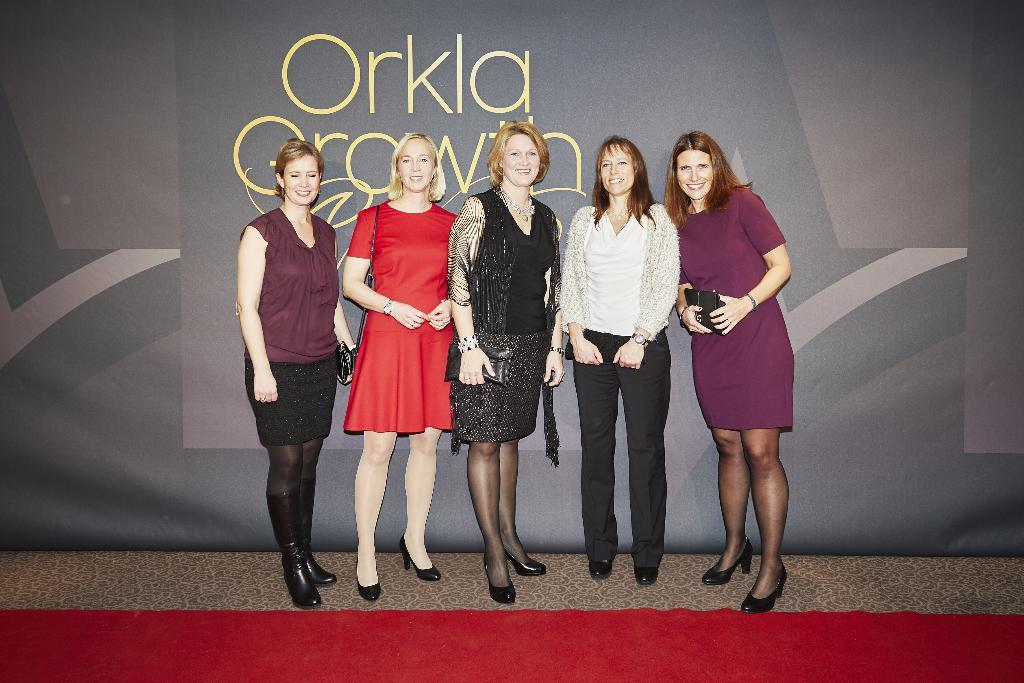How many women are present in the image? There are five women in the image. What is the surface the women are standing on? The women are standing on the floor. What can be seen at the bottom of the image? There is a red carpet at the bottom of the image. What is visible in the background of the image? There is a banner in the background of the image. What type of steel is used to construct the quince in the image? There is no steel or quince present in the image. 